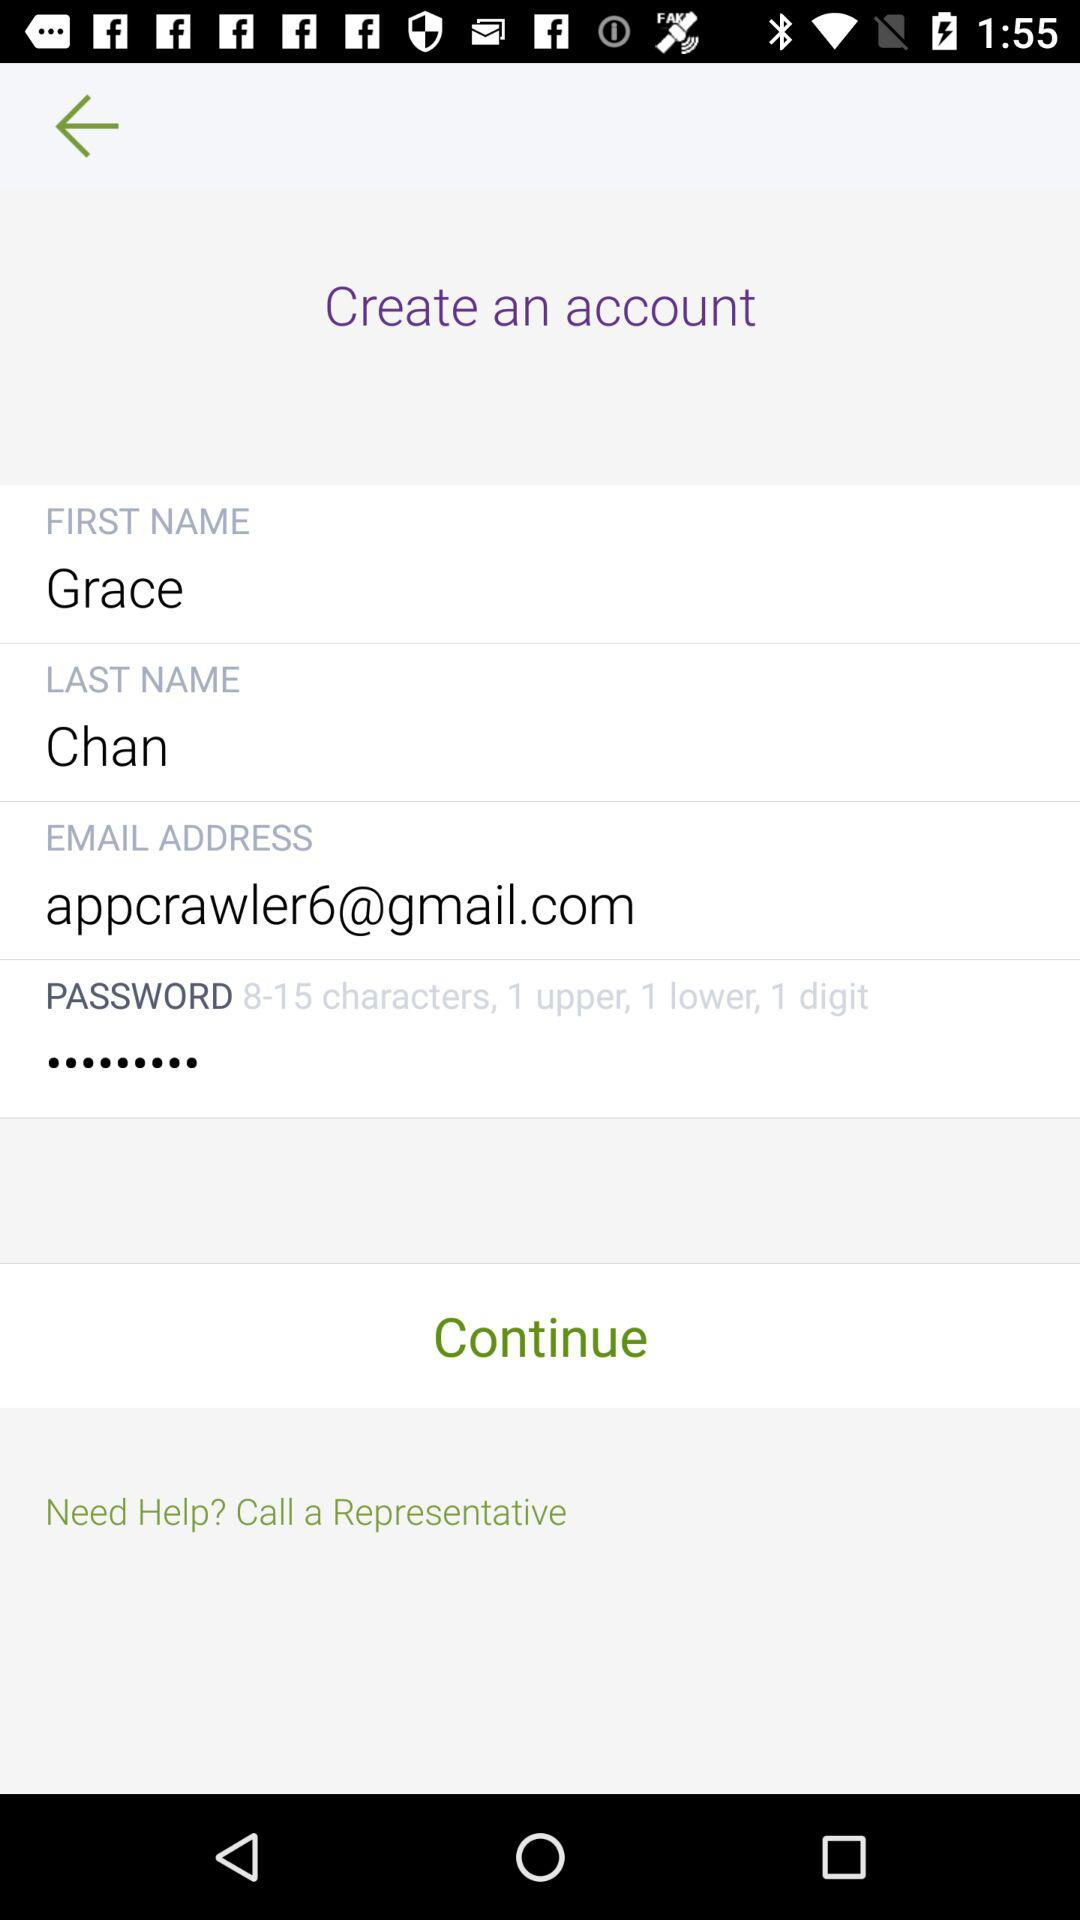What is the last name? The last name is Chan. 